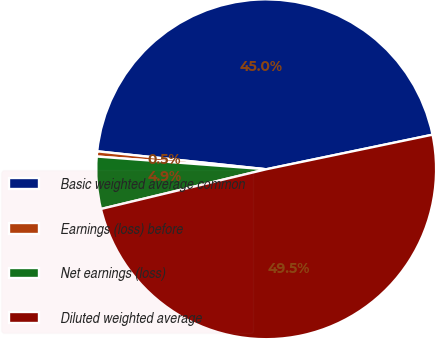Convert chart. <chart><loc_0><loc_0><loc_500><loc_500><pie_chart><fcel>Basic weighted average common<fcel>Earnings (loss) before<fcel>Net earnings (loss)<fcel>Diluted weighted average<nl><fcel>45.05%<fcel>0.49%<fcel>4.95%<fcel>49.51%<nl></chart> 